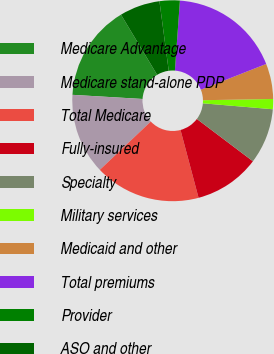<chart> <loc_0><loc_0><loc_500><loc_500><pie_chart><fcel>Medicare Advantage<fcel>Medicare stand-alone PDP<fcel>Total Medicare<fcel>Fully-insured<fcel>Specialty<fcel>Military services<fcel>Medicaid and other<fcel>Total premiums<fcel>Provider<fcel>ASO and other<nl><fcel>15.45%<fcel>13.01%<fcel>17.07%<fcel>10.57%<fcel>8.94%<fcel>1.63%<fcel>5.69%<fcel>17.89%<fcel>3.25%<fcel>6.5%<nl></chart> 